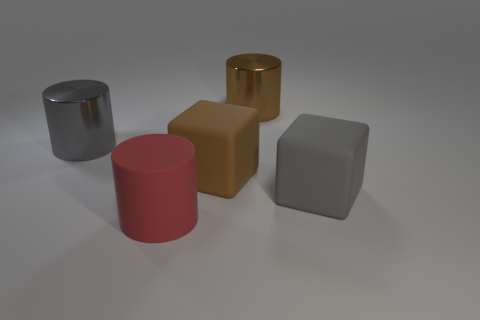What materials do these objects appear to be made of, and can you describe their finishes? Certainly, the image shows a collection of five objects, each with a distinct material and finish. The cylinder on the left has a shiny, metallic finish suggesting it could be made of stainless steel or aluminum. The brown block in the middle has a matte finish perhaps indicative of a plastic or painted wooden material. Right behind it, a golden cube also features a shiny finish, similar to brass or a gold-colored metal. The red cylinder in the front has a matte, red-painted finish, which could be either metal or wood. And lastly, the gray cube has a soft, rubber-like appearance with a satin finish. 